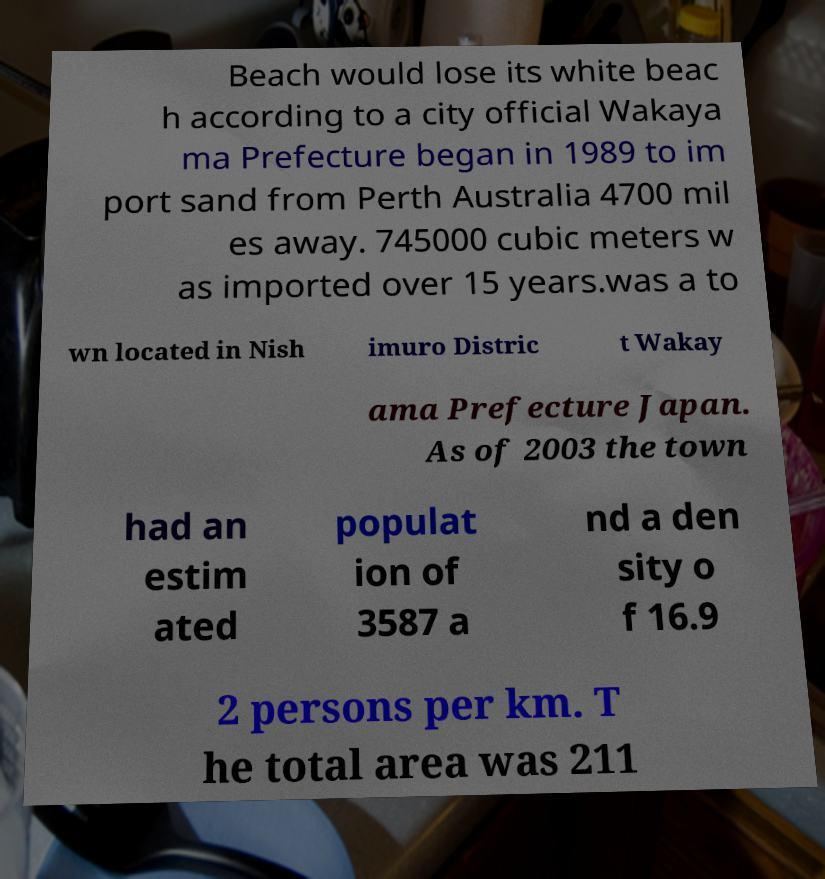I need the written content from this picture converted into text. Can you do that? Beach would lose its white beac h according to a city official Wakaya ma Prefecture began in 1989 to im port sand from Perth Australia 4700 mil es away. 745000 cubic meters w as imported over 15 years.was a to wn located in Nish imuro Distric t Wakay ama Prefecture Japan. As of 2003 the town had an estim ated populat ion of 3587 a nd a den sity o f 16.9 2 persons per km. T he total area was 211 